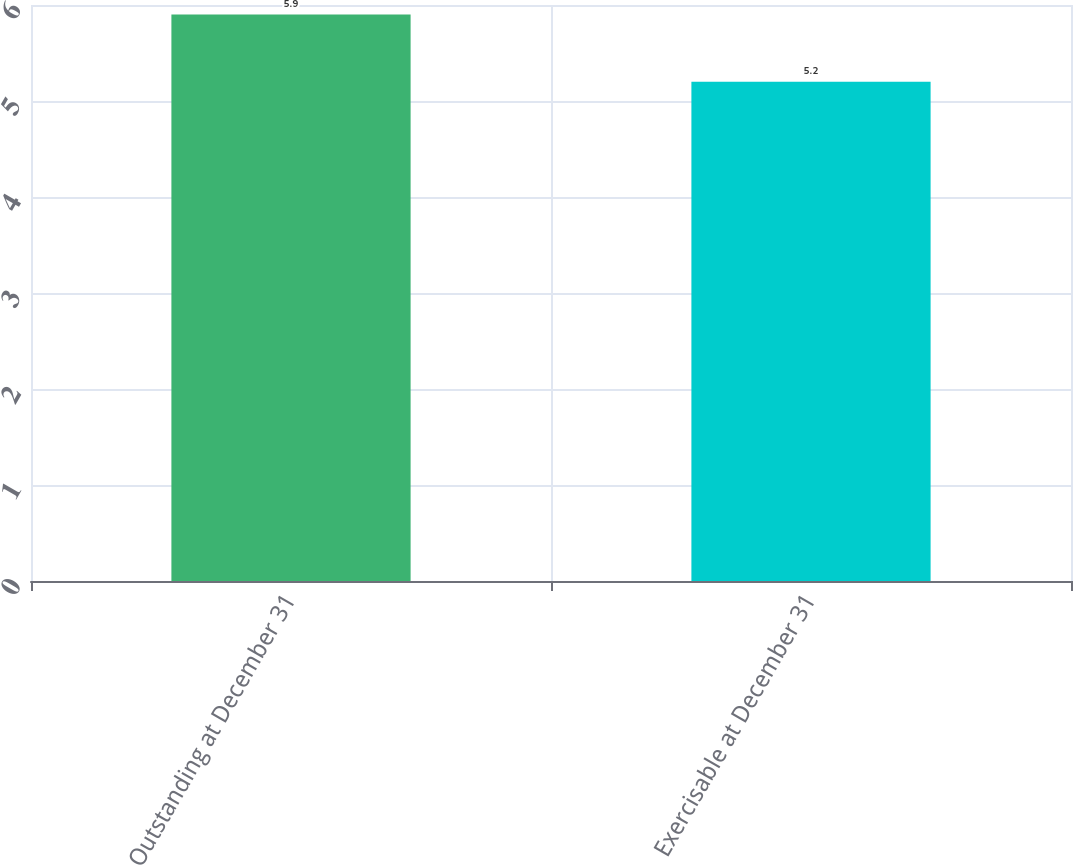Convert chart to OTSL. <chart><loc_0><loc_0><loc_500><loc_500><bar_chart><fcel>Outstanding at December 31<fcel>Exercisable at December 31<nl><fcel>5.9<fcel>5.2<nl></chart> 